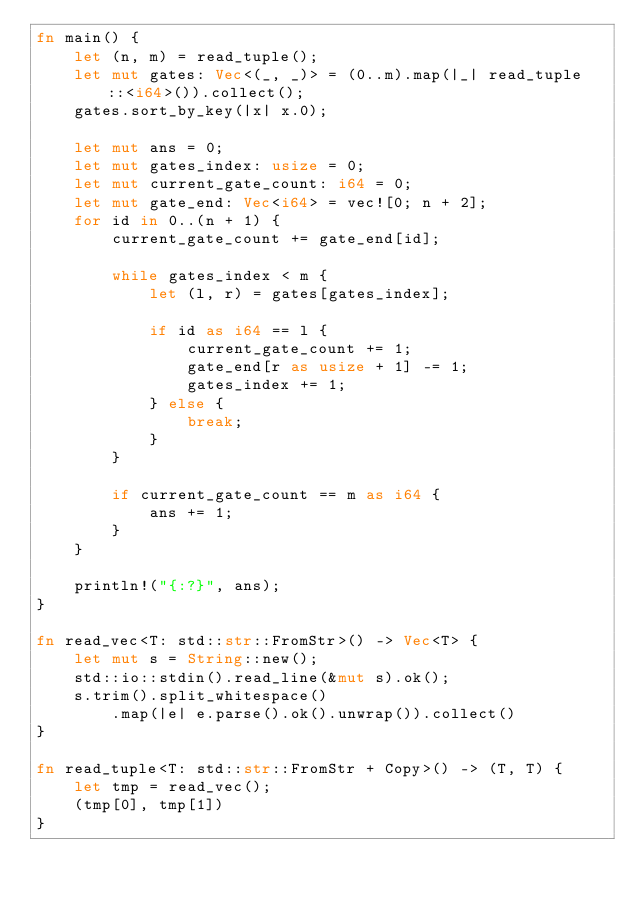<code> <loc_0><loc_0><loc_500><loc_500><_Rust_>fn main() {
    let (n, m) = read_tuple();
    let mut gates: Vec<(_, _)> = (0..m).map(|_| read_tuple::<i64>()).collect();
    gates.sort_by_key(|x| x.0);

    let mut ans = 0;
    let mut gates_index: usize = 0;
    let mut current_gate_count: i64 = 0;
    let mut gate_end: Vec<i64> = vec![0; n + 2];
    for id in 0..(n + 1) {
        current_gate_count += gate_end[id];

        while gates_index < m {
            let (l, r) = gates[gates_index];

            if id as i64 == l {
                current_gate_count += 1;
                gate_end[r as usize + 1] -= 1;
                gates_index += 1;
            } else {
                break;
            }
        }

        if current_gate_count == m as i64 {
            ans += 1;
        }
    }

    println!("{:?}", ans);
}

fn read_vec<T: std::str::FromStr>() -> Vec<T> {
    let mut s = String::new();
    std::io::stdin().read_line(&mut s).ok();
    s.trim().split_whitespace()
        .map(|e| e.parse().ok().unwrap()).collect()
}

fn read_tuple<T: std::str::FromStr + Copy>() -> (T, T) {
    let tmp = read_vec();
    (tmp[0], tmp[1])
}</code> 